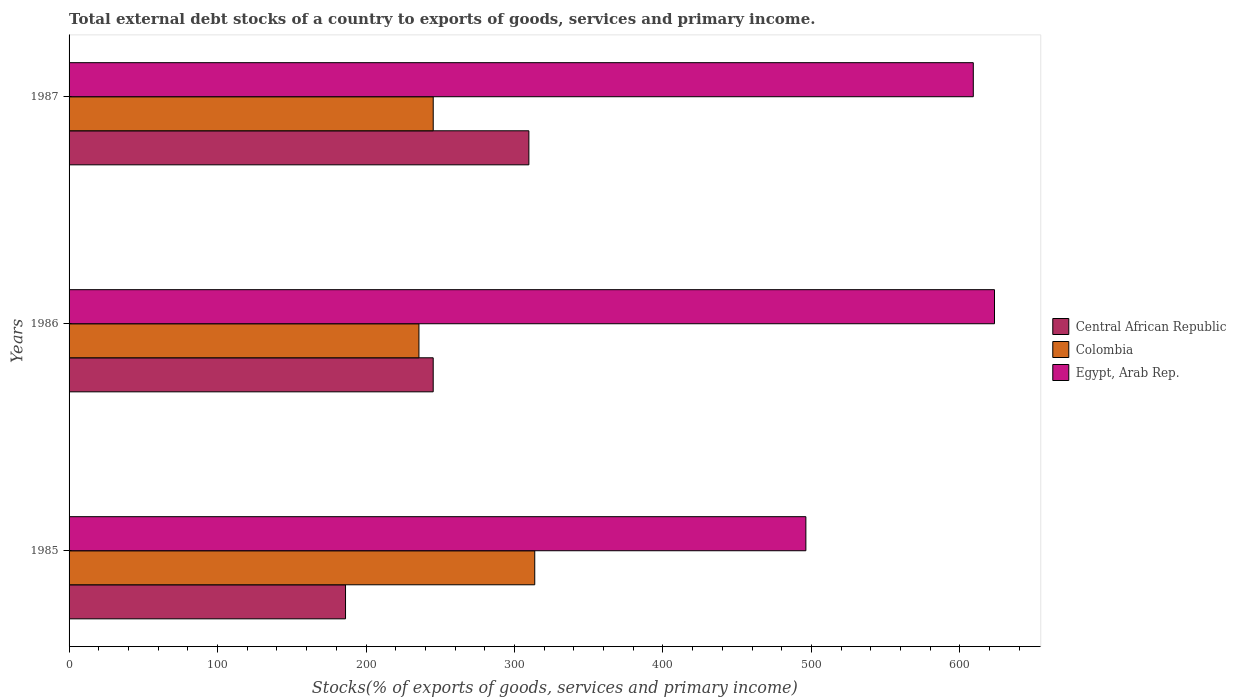How many different coloured bars are there?
Your answer should be very brief. 3. How many groups of bars are there?
Offer a very short reply. 3. Are the number of bars per tick equal to the number of legend labels?
Provide a succinct answer. Yes. How many bars are there on the 2nd tick from the bottom?
Your response must be concise. 3. What is the total debt stocks in Colombia in 1985?
Provide a succinct answer. 313.64. Across all years, what is the maximum total debt stocks in Colombia?
Make the answer very short. 313.64. Across all years, what is the minimum total debt stocks in Egypt, Arab Rep.?
Provide a succinct answer. 496.24. What is the total total debt stocks in Colombia in the graph?
Your answer should be compact. 794.52. What is the difference between the total debt stocks in Egypt, Arab Rep. in 1986 and that in 1987?
Give a very brief answer. 14.29. What is the difference between the total debt stocks in Colombia in 1987 and the total debt stocks in Central African Republic in 1985?
Offer a very short reply. 59.05. What is the average total debt stocks in Colombia per year?
Ensure brevity in your answer.  264.84. In the year 1985, what is the difference between the total debt stocks in Egypt, Arab Rep. and total debt stocks in Central African Republic?
Ensure brevity in your answer.  310.04. What is the ratio of the total debt stocks in Egypt, Arab Rep. in 1985 to that in 1986?
Your response must be concise. 0.8. Is the difference between the total debt stocks in Egypt, Arab Rep. in 1986 and 1987 greater than the difference between the total debt stocks in Central African Republic in 1986 and 1987?
Your answer should be compact. Yes. What is the difference between the highest and the second highest total debt stocks in Colombia?
Your answer should be compact. 68.38. What is the difference between the highest and the lowest total debt stocks in Central African Republic?
Your response must be concise. 123.48. In how many years, is the total debt stocks in Egypt, Arab Rep. greater than the average total debt stocks in Egypt, Arab Rep. taken over all years?
Provide a short and direct response. 2. Is the sum of the total debt stocks in Egypt, Arab Rep. in 1985 and 1987 greater than the maximum total debt stocks in Central African Republic across all years?
Your response must be concise. Yes. What does the 1st bar from the top in 1986 represents?
Your answer should be very brief. Egypt, Arab Rep. What does the 2nd bar from the bottom in 1986 represents?
Your response must be concise. Colombia. What is the difference between two consecutive major ticks on the X-axis?
Give a very brief answer. 100. Are the values on the major ticks of X-axis written in scientific E-notation?
Make the answer very short. No. Does the graph contain grids?
Your response must be concise. No. How many legend labels are there?
Your answer should be compact. 3. What is the title of the graph?
Offer a terse response. Total external debt stocks of a country to exports of goods, services and primary income. Does "Estonia" appear as one of the legend labels in the graph?
Your answer should be very brief. No. What is the label or title of the X-axis?
Make the answer very short. Stocks(% of exports of goods, services and primary income). What is the Stocks(% of exports of goods, services and primary income) of Central African Republic in 1985?
Your answer should be very brief. 186.2. What is the Stocks(% of exports of goods, services and primary income) in Colombia in 1985?
Offer a terse response. 313.64. What is the Stocks(% of exports of goods, services and primary income) of Egypt, Arab Rep. in 1985?
Your answer should be very brief. 496.24. What is the Stocks(% of exports of goods, services and primary income) of Central African Republic in 1986?
Give a very brief answer. 245.24. What is the Stocks(% of exports of goods, services and primary income) of Colombia in 1986?
Make the answer very short. 235.63. What is the Stocks(% of exports of goods, services and primary income) in Egypt, Arab Rep. in 1986?
Provide a succinct answer. 623.28. What is the Stocks(% of exports of goods, services and primary income) in Central African Republic in 1987?
Provide a short and direct response. 309.68. What is the Stocks(% of exports of goods, services and primary income) of Colombia in 1987?
Offer a very short reply. 245.25. What is the Stocks(% of exports of goods, services and primary income) in Egypt, Arab Rep. in 1987?
Offer a very short reply. 608.99. Across all years, what is the maximum Stocks(% of exports of goods, services and primary income) in Central African Republic?
Offer a terse response. 309.68. Across all years, what is the maximum Stocks(% of exports of goods, services and primary income) of Colombia?
Give a very brief answer. 313.64. Across all years, what is the maximum Stocks(% of exports of goods, services and primary income) of Egypt, Arab Rep.?
Provide a succinct answer. 623.28. Across all years, what is the minimum Stocks(% of exports of goods, services and primary income) of Central African Republic?
Your answer should be very brief. 186.2. Across all years, what is the minimum Stocks(% of exports of goods, services and primary income) in Colombia?
Your answer should be very brief. 235.63. Across all years, what is the minimum Stocks(% of exports of goods, services and primary income) in Egypt, Arab Rep.?
Offer a very short reply. 496.24. What is the total Stocks(% of exports of goods, services and primary income) in Central African Republic in the graph?
Provide a short and direct response. 741.13. What is the total Stocks(% of exports of goods, services and primary income) in Colombia in the graph?
Offer a very short reply. 794.52. What is the total Stocks(% of exports of goods, services and primary income) of Egypt, Arab Rep. in the graph?
Keep it short and to the point. 1728.51. What is the difference between the Stocks(% of exports of goods, services and primary income) in Central African Republic in 1985 and that in 1986?
Your answer should be very brief. -59.04. What is the difference between the Stocks(% of exports of goods, services and primary income) of Colombia in 1985 and that in 1986?
Your answer should be compact. 78. What is the difference between the Stocks(% of exports of goods, services and primary income) in Egypt, Arab Rep. in 1985 and that in 1986?
Your response must be concise. -127.04. What is the difference between the Stocks(% of exports of goods, services and primary income) in Central African Republic in 1985 and that in 1987?
Offer a very short reply. -123.48. What is the difference between the Stocks(% of exports of goods, services and primary income) of Colombia in 1985 and that in 1987?
Provide a succinct answer. 68.38. What is the difference between the Stocks(% of exports of goods, services and primary income) in Egypt, Arab Rep. in 1985 and that in 1987?
Provide a short and direct response. -112.75. What is the difference between the Stocks(% of exports of goods, services and primary income) in Central African Republic in 1986 and that in 1987?
Offer a very short reply. -64.44. What is the difference between the Stocks(% of exports of goods, services and primary income) of Colombia in 1986 and that in 1987?
Make the answer very short. -9.62. What is the difference between the Stocks(% of exports of goods, services and primary income) in Egypt, Arab Rep. in 1986 and that in 1987?
Offer a terse response. 14.29. What is the difference between the Stocks(% of exports of goods, services and primary income) in Central African Republic in 1985 and the Stocks(% of exports of goods, services and primary income) in Colombia in 1986?
Provide a succinct answer. -49.43. What is the difference between the Stocks(% of exports of goods, services and primary income) in Central African Republic in 1985 and the Stocks(% of exports of goods, services and primary income) in Egypt, Arab Rep. in 1986?
Provide a short and direct response. -437.08. What is the difference between the Stocks(% of exports of goods, services and primary income) of Colombia in 1985 and the Stocks(% of exports of goods, services and primary income) of Egypt, Arab Rep. in 1986?
Provide a short and direct response. -309.64. What is the difference between the Stocks(% of exports of goods, services and primary income) in Central African Republic in 1985 and the Stocks(% of exports of goods, services and primary income) in Colombia in 1987?
Keep it short and to the point. -59.05. What is the difference between the Stocks(% of exports of goods, services and primary income) of Central African Republic in 1985 and the Stocks(% of exports of goods, services and primary income) of Egypt, Arab Rep. in 1987?
Your answer should be very brief. -422.79. What is the difference between the Stocks(% of exports of goods, services and primary income) in Colombia in 1985 and the Stocks(% of exports of goods, services and primary income) in Egypt, Arab Rep. in 1987?
Your response must be concise. -295.36. What is the difference between the Stocks(% of exports of goods, services and primary income) in Central African Republic in 1986 and the Stocks(% of exports of goods, services and primary income) in Colombia in 1987?
Your answer should be very brief. -0.01. What is the difference between the Stocks(% of exports of goods, services and primary income) in Central African Republic in 1986 and the Stocks(% of exports of goods, services and primary income) in Egypt, Arab Rep. in 1987?
Your answer should be very brief. -363.75. What is the difference between the Stocks(% of exports of goods, services and primary income) in Colombia in 1986 and the Stocks(% of exports of goods, services and primary income) in Egypt, Arab Rep. in 1987?
Your answer should be compact. -373.36. What is the average Stocks(% of exports of goods, services and primary income) of Central African Republic per year?
Give a very brief answer. 247.04. What is the average Stocks(% of exports of goods, services and primary income) in Colombia per year?
Provide a succinct answer. 264.84. What is the average Stocks(% of exports of goods, services and primary income) of Egypt, Arab Rep. per year?
Give a very brief answer. 576.17. In the year 1985, what is the difference between the Stocks(% of exports of goods, services and primary income) in Central African Republic and Stocks(% of exports of goods, services and primary income) in Colombia?
Your response must be concise. -127.44. In the year 1985, what is the difference between the Stocks(% of exports of goods, services and primary income) in Central African Republic and Stocks(% of exports of goods, services and primary income) in Egypt, Arab Rep.?
Your answer should be very brief. -310.04. In the year 1985, what is the difference between the Stocks(% of exports of goods, services and primary income) in Colombia and Stocks(% of exports of goods, services and primary income) in Egypt, Arab Rep.?
Give a very brief answer. -182.6. In the year 1986, what is the difference between the Stocks(% of exports of goods, services and primary income) in Central African Republic and Stocks(% of exports of goods, services and primary income) in Colombia?
Give a very brief answer. 9.61. In the year 1986, what is the difference between the Stocks(% of exports of goods, services and primary income) in Central African Republic and Stocks(% of exports of goods, services and primary income) in Egypt, Arab Rep.?
Offer a very short reply. -378.03. In the year 1986, what is the difference between the Stocks(% of exports of goods, services and primary income) in Colombia and Stocks(% of exports of goods, services and primary income) in Egypt, Arab Rep.?
Make the answer very short. -387.64. In the year 1987, what is the difference between the Stocks(% of exports of goods, services and primary income) of Central African Republic and Stocks(% of exports of goods, services and primary income) of Colombia?
Provide a short and direct response. 64.43. In the year 1987, what is the difference between the Stocks(% of exports of goods, services and primary income) in Central African Republic and Stocks(% of exports of goods, services and primary income) in Egypt, Arab Rep.?
Your answer should be very brief. -299.31. In the year 1987, what is the difference between the Stocks(% of exports of goods, services and primary income) in Colombia and Stocks(% of exports of goods, services and primary income) in Egypt, Arab Rep.?
Offer a very short reply. -363.74. What is the ratio of the Stocks(% of exports of goods, services and primary income) of Central African Republic in 1985 to that in 1986?
Your answer should be compact. 0.76. What is the ratio of the Stocks(% of exports of goods, services and primary income) in Colombia in 1985 to that in 1986?
Your answer should be very brief. 1.33. What is the ratio of the Stocks(% of exports of goods, services and primary income) of Egypt, Arab Rep. in 1985 to that in 1986?
Make the answer very short. 0.8. What is the ratio of the Stocks(% of exports of goods, services and primary income) in Central African Republic in 1985 to that in 1987?
Give a very brief answer. 0.6. What is the ratio of the Stocks(% of exports of goods, services and primary income) in Colombia in 1985 to that in 1987?
Provide a succinct answer. 1.28. What is the ratio of the Stocks(% of exports of goods, services and primary income) in Egypt, Arab Rep. in 1985 to that in 1987?
Give a very brief answer. 0.81. What is the ratio of the Stocks(% of exports of goods, services and primary income) of Central African Republic in 1986 to that in 1987?
Give a very brief answer. 0.79. What is the ratio of the Stocks(% of exports of goods, services and primary income) in Colombia in 1986 to that in 1987?
Your answer should be very brief. 0.96. What is the ratio of the Stocks(% of exports of goods, services and primary income) in Egypt, Arab Rep. in 1986 to that in 1987?
Make the answer very short. 1.02. What is the difference between the highest and the second highest Stocks(% of exports of goods, services and primary income) in Central African Republic?
Your answer should be very brief. 64.44. What is the difference between the highest and the second highest Stocks(% of exports of goods, services and primary income) of Colombia?
Offer a terse response. 68.38. What is the difference between the highest and the second highest Stocks(% of exports of goods, services and primary income) in Egypt, Arab Rep.?
Offer a very short reply. 14.29. What is the difference between the highest and the lowest Stocks(% of exports of goods, services and primary income) in Central African Republic?
Provide a succinct answer. 123.48. What is the difference between the highest and the lowest Stocks(% of exports of goods, services and primary income) of Colombia?
Ensure brevity in your answer.  78. What is the difference between the highest and the lowest Stocks(% of exports of goods, services and primary income) of Egypt, Arab Rep.?
Your answer should be compact. 127.04. 